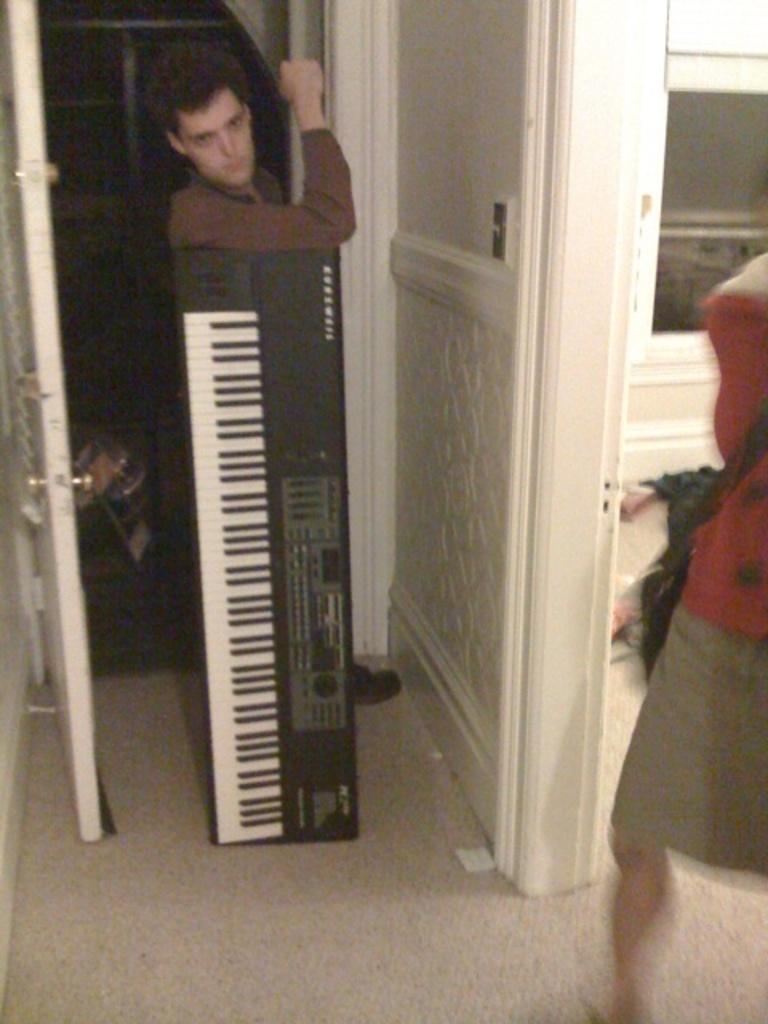How would you summarize this image in a sentence or two? There is a person standing in the center and this is a piano. This is a door which is used to enter into the room. I think there is a woman on the right side. 